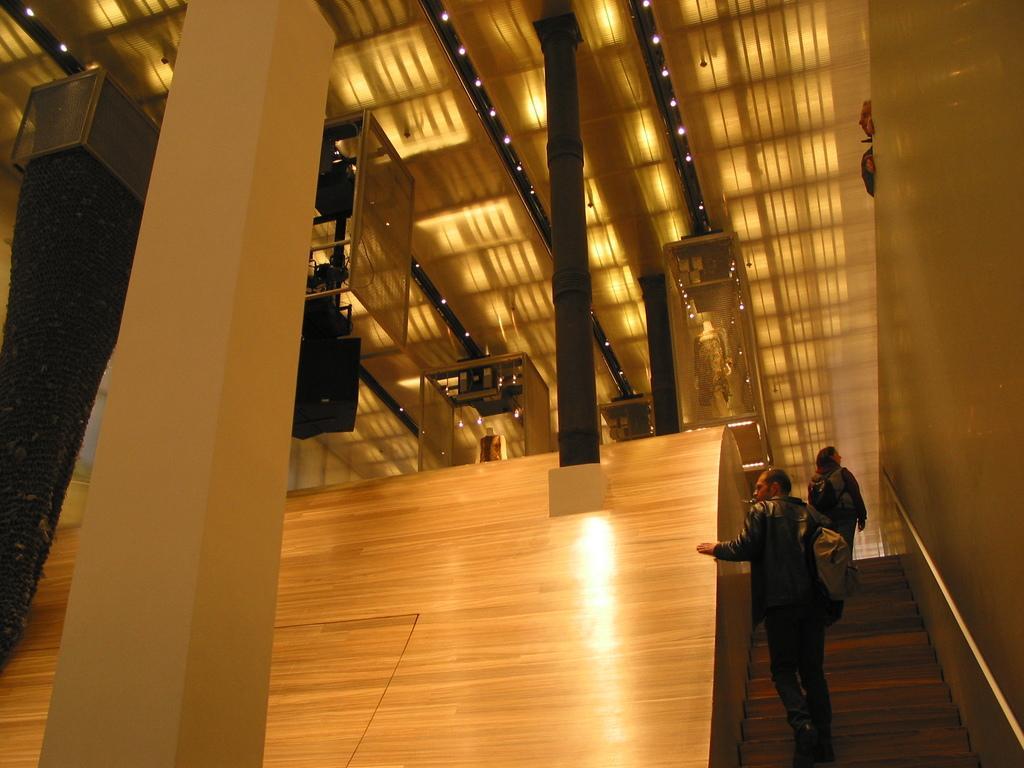In one or two sentences, can you explain what this image depicts? In this image, we can see some pillars. We can see some mannequins with clothes. We can see some boxes. We can also see some objects on the left. There are a few people. We can see the ground and the wall. We can also see the roof with lights. 